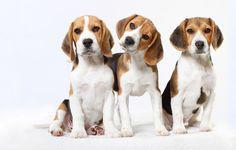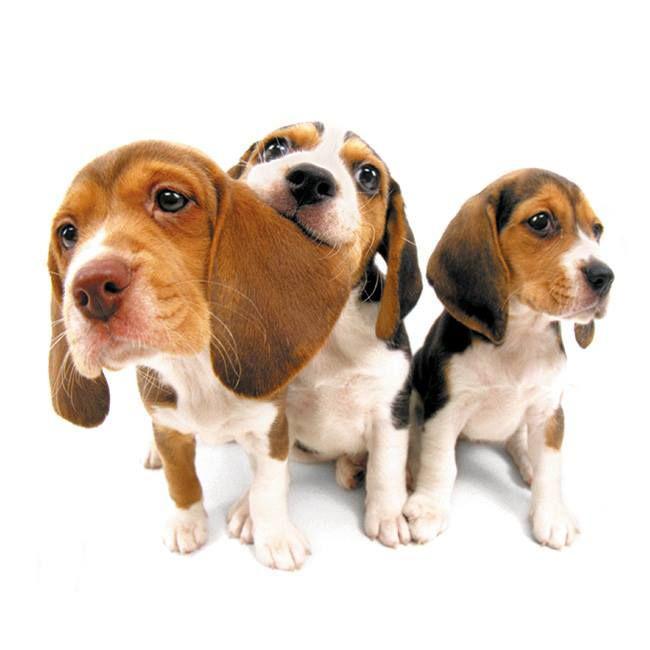The first image is the image on the left, the second image is the image on the right. Considering the images on both sides, is "There are three dogs in each of the images." valid? Answer yes or no. Yes. 